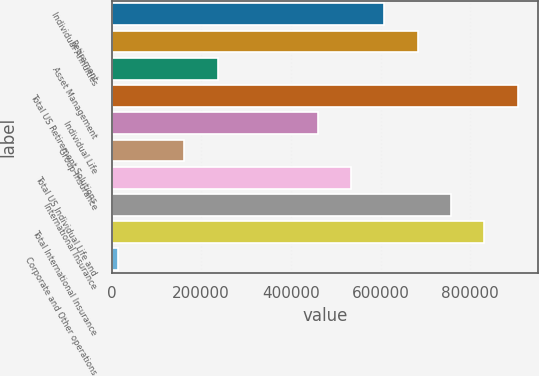Convert chart to OTSL. <chart><loc_0><loc_0><loc_500><loc_500><bar_chart><fcel>Individual Annuities<fcel>Retirement<fcel>Asset Management<fcel>Total US Retirement Solutions<fcel>Individual Life<fcel>Group Insurance<fcel>Total US Individual Life and<fcel>International Insurance<fcel>Total International Insurance<fcel>Corporate and Other operations<nl><fcel>608535<fcel>682895<fcel>236734<fcel>905975<fcel>459815<fcel>162374<fcel>534175<fcel>757255<fcel>831615<fcel>13654<nl></chart> 